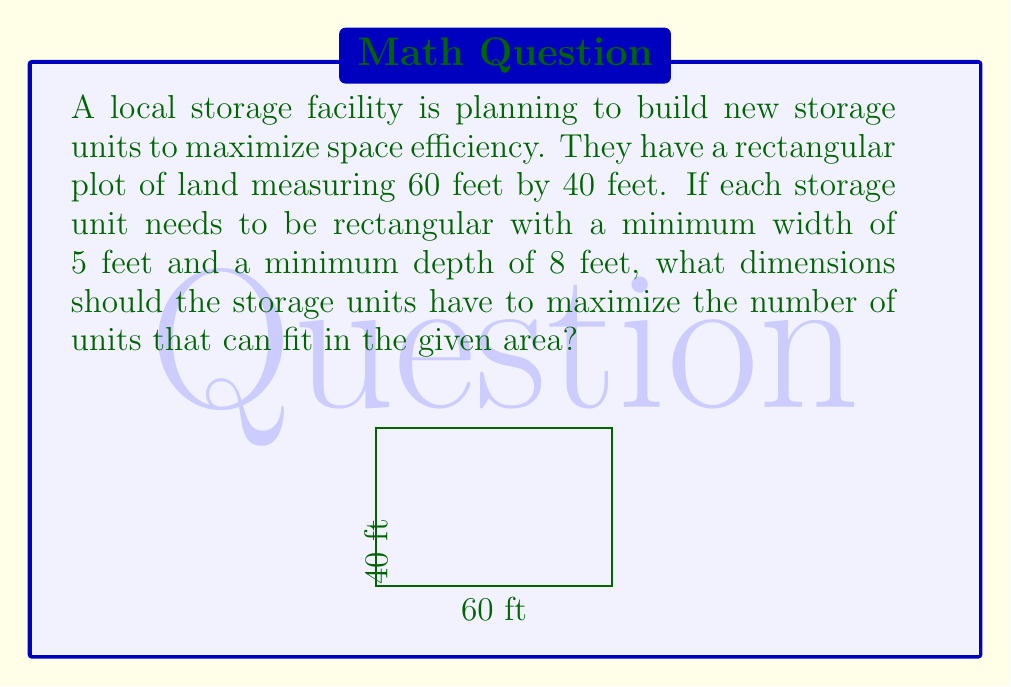Help me with this question. Let's approach this step-by-step:

1) Let $x$ be the width and $y$ be the depth of each storage unit.

2) The number of units that can fit along the width of the plot is $\lfloor \frac{60}{x} \rfloor$, where $\lfloor \rfloor$ denotes the floor function.

3) Similarly, the number of units that can fit along the depth is $\lfloor \frac{40}{y} \rfloor$.

4) The total number of units, $N$, is the product of these two:

   $N = \lfloor \frac{60}{x} \rfloor \cdot \lfloor \frac{40}{y} \rfloor$

5) We need to maximize $N$ subject to the constraints:
   $x \geq 5$, $y \geq 8$, and $x$ and $y$ are integers.

6) We can use a simple computational approach. Let's calculate $N$ for all possible integer values of $x$ and $y$ within our constraints:

   For $x = 5$ to $20$ (since $3 \cdot 20 = 60$)
   For $y = 8$ to $20$ (since $2 \cdot 20 = 40$)

7) After calculations, we find that the maximum value of $N$ is 48, which occurs when $x = 10$ and $y = 10$.

This means the storage units should be 10 feet wide and 10 feet deep to maximize the number of units.

With these dimensions:
- 6 units fit along the width (60 ÷ 10 = 6)
- 4 units fit along the depth (40 ÷ 10 = 4)
- Total units: 6 * 4 = 24

This configuration maximizes space efficiency while meeting the minimum size requirements.
Answer: The storage units should be 10 feet wide and 10 feet deep to maximize the number of units to 24. 